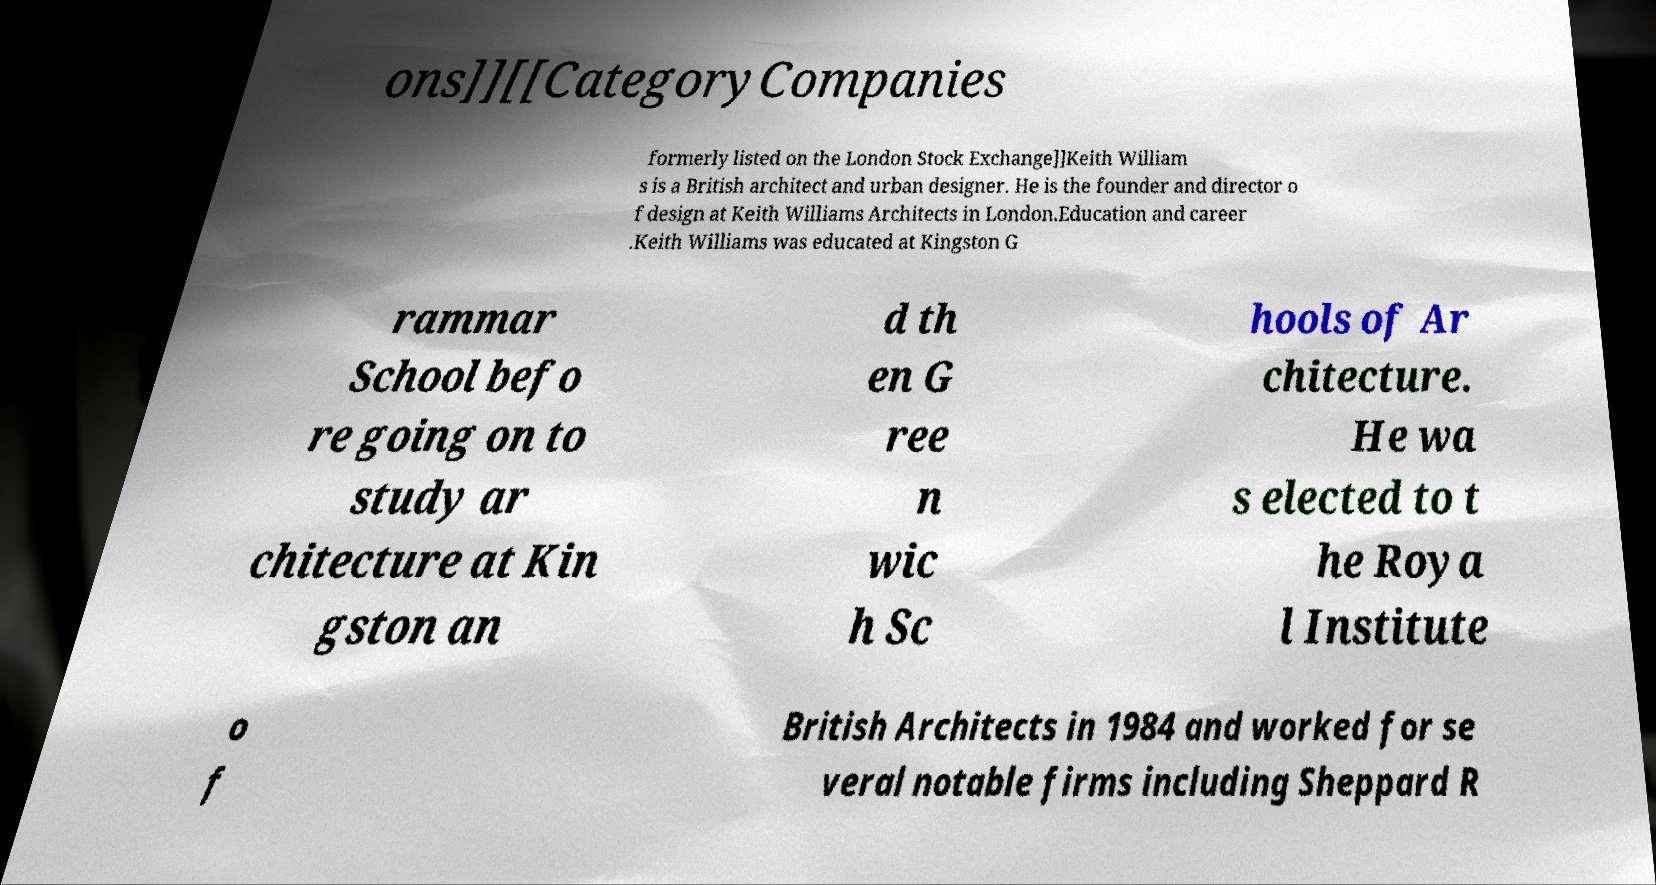Could you extract and type out the text from this image? ons]][[CategoryCompanies formerly listed on the London Stock Exchange]]Keith William s is a British architect and urban designer. He is the founder and director o f design at Keith Williams Architects in London.Education and career .Keith Williams was educated at Kingston G rammar School befo re going on to study ar chitecture at Kin gston an d th en G ree n wic h Sc hools of Ar chitecture. He wa s elected to t he Roya l Institute o f British Architects in 1984 and worked for se veral notable firms including Sheppard R 